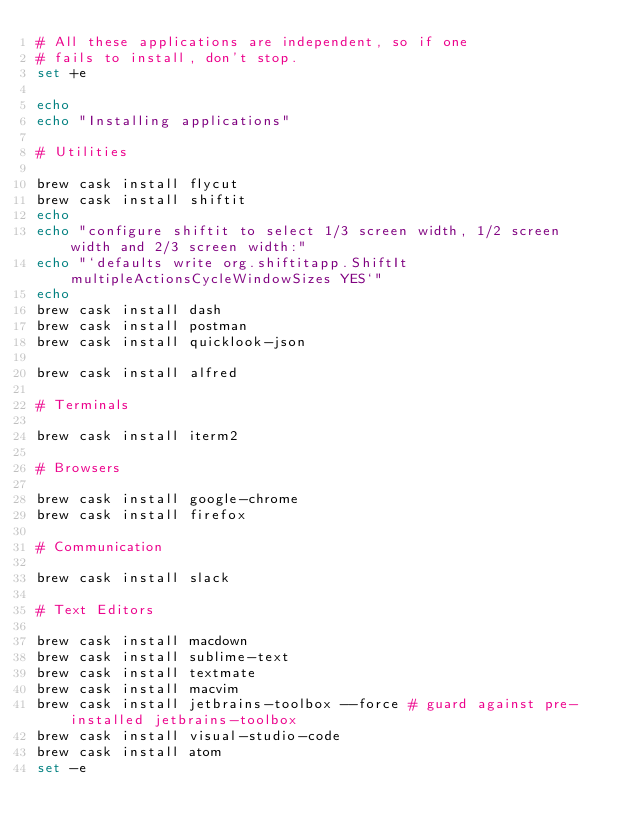<code> <loc_0><loc_0><loc_500><loc_500><_Bash_># All these applications are independent, so if one
# fails to install, don't stop.
set +e

echo
echo "Installing applications"

# Utilities

brew cask install flycut
brew cask install shiftit
echo
echo "configure shiftit to select 1/3 screen width, 1/2 screen width and 2/3 screen width:"
echo "`defaults write org.shiftitapp.ShiftIt multipleActionsCycleWindowSizes YES`"
echo
brew cask install dash
brew cask install postman
brew cask install quicklook-json

brew cask install alfred

# Terminals

brew cask install iterm2

# Browsers

brew cask install google-chrome
brew cask install firefox

# Communication

brew cask install slack

# Text Editors

brew cask install macdown
brew cask install sublime-text
brew cask install textmate
brew cask install macvim
brew cask install jetbrains-toolbox --force # guard against pre-installed jetbrains-toolbox
brew cask install visual-studio-code
brew cask install atom
set -e
</code> 